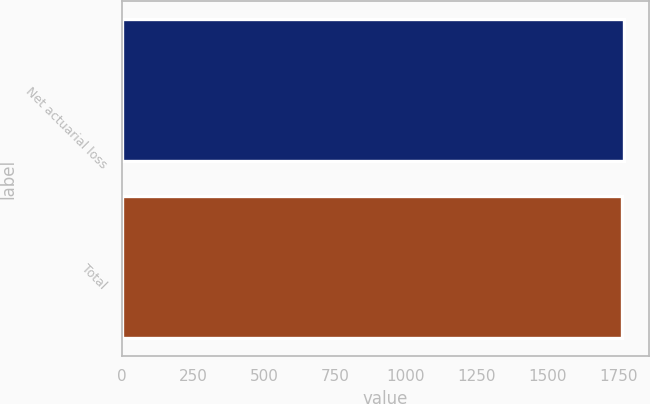Convert chart. <chart><loc_0><loc_0><loc_500><loc_500><bar_chart><fcel>Net actuarial loss<fcel>Total<nl><fcel>1769<fcel>1762<nl></chart> 